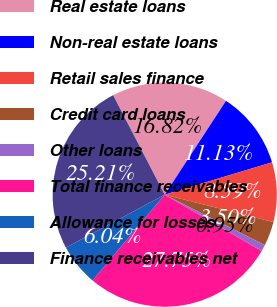Convert chart to OTSL. <chart><loc_0><loc_0><loc_500><loc_500><pie_chart><fcel>Real estate loans<fcel>Non-real estate loans<fcel>Retail sales finance<fcel>Credit card loans<fcel>Other loans<fcel>Total finance receivables<fcel>Allowance for losses<fcel>Finance receivables net<nl><fcel>16.82%<fcel>11.13%<fcel>8.59%<fcel>3.5%<fcel>0.95%<fcel>27.75%<fcel>6.04%<fcel>25.21%<nl></chart> 